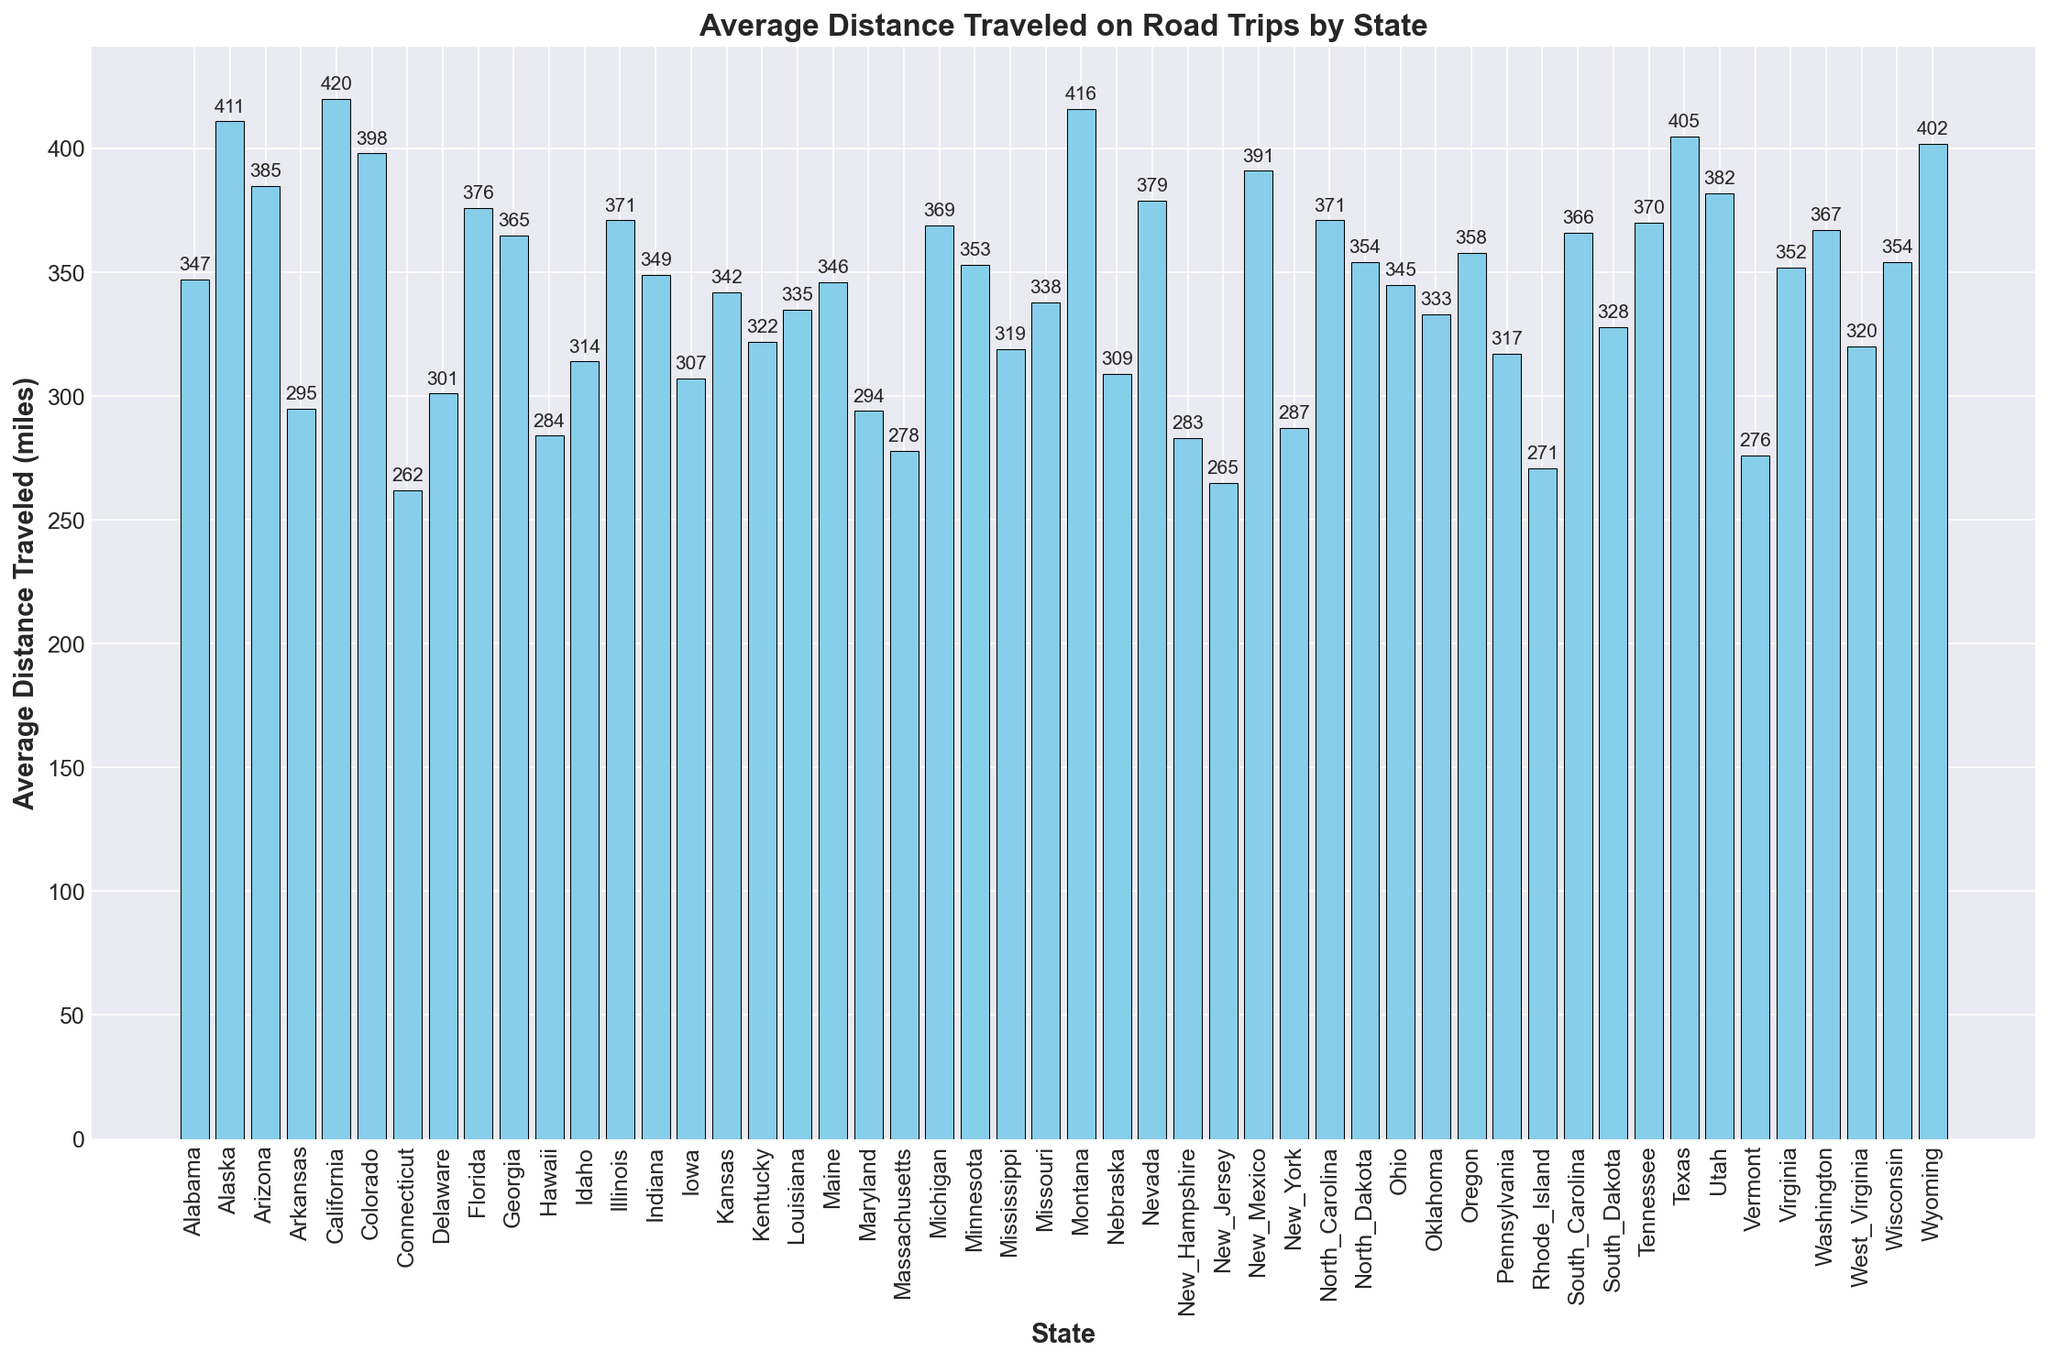Which state has the highest average distance traveled? Look at the height of the bars in the figure. California has the tallest bar, indicating the highest average distance.
Answer: California What is the difference in average distance traveled between California and Connecticut? California's distance is 420 miles and Connecticut's is 262 miles. The difference is 420 - 262.
Answer: 158 miles Which states have an average distance traveled that is greater than 400 miles? The bars that extend beyond the 400-mile mark are for Alaska, California, Montana, Texas, and Wyoming.
Answer: Alaska, California, Montana, Texas, Wyoming Which state has the smallest average distance traveled on road trips? Identify the shortest bar in the figure. The shortest bar belongs to Connecticut.
Answer: Connecticut What is the total average distance traveled by road trips for Alabama, Arkansas, and Florida? Sum the average distances for Alabama (347 miles), Arkansas (295 miles), and Florida (376 miles). The total is 347 + 295 + 376.
Answer: 1018 miles Is the average distance traveled in Georgia greater or less than in Virginia? Compare the height of Georgia's bar (365 miles) with Virginia’s bar (352 miles).
Answer: Greater What is the median value of average distance traveled on road trips across all states? Arrange all values in ascending order and locate the middle value. With 50 states, the median will be the average of the 25th and 26th values. The distances are sorted, and the middle values are Kansas (342 miles) and Louisiana (335 miles). The average is (342 + 335) / 2.
Answer: 338.5 miles Which five states have the highest average distance traveled? Identify the five tallest bars in the figure. The states are California, Texas, Montana, Wyoming, and Alaska.
Answer: California, Texas, Montana, Wyoming, Alaska How does the average distance traveled in Illinois compare to Florida? Compare the height of Illinois's bar (371 miles) with Florida's bar (376 miles).
Answer: Less 